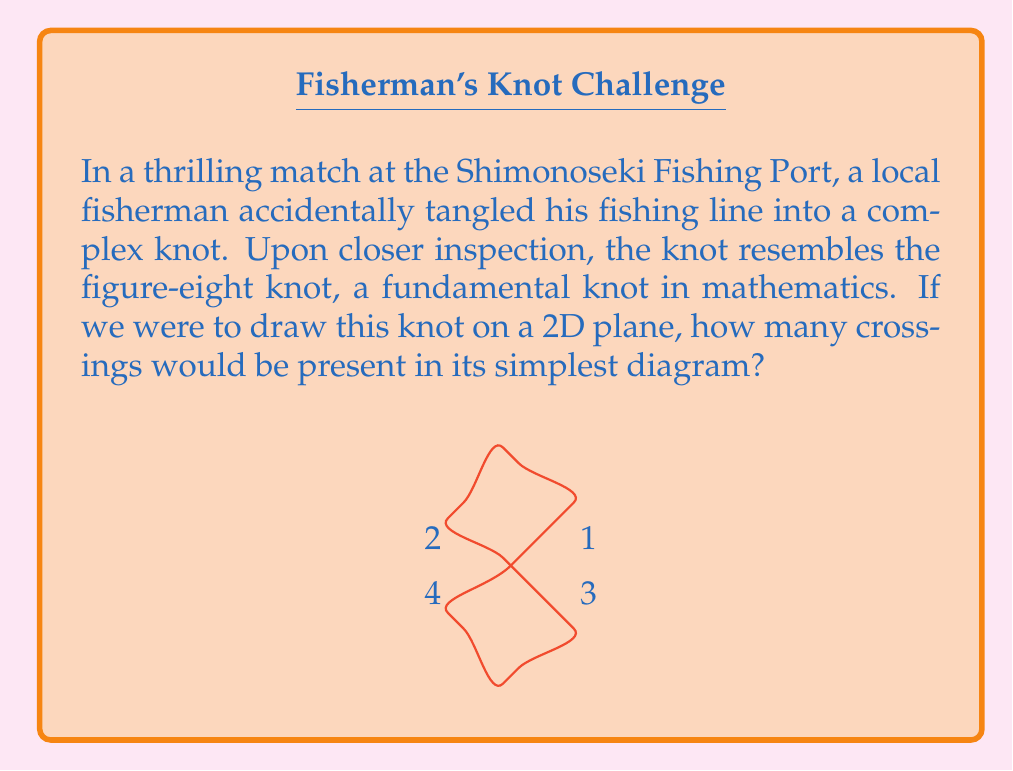Give your solution to this math problem. To determine the crossing number of a simple knot diagram, we need to follow these steps:

1) First, we need to understand what a crossing number is. The crossing number of a knot is the minimum number of crossings that occur in any projection of the knot onto a plane.

2) For the figure-eight knot, which is what our fisherman's tangled line resembles, we need to analyze its simplest diagram.

3) In the simplest diagram of a figure-eight knot, we can observe:
   - The knot crosses over itself four times.
   - These crossings are essential and cannot be removed or simplified further without changing the knot type.

4) We can verify this by tracing the knot:
   - Starting from any point, follow the line.
   - Count each time the line passes over or under another part of itself.
   - For the figure-eight knot, this count will always be 4 in its simplest form.

5) It's important to note that while more complex representations of the figure-eight knot might have more crossings, we're interested in the minimum number of crossings in any projection.

6) The figure-eight knot is known to be a prime knot, meaning it cannot be decomposed into simpler knots. This supports the fact that 4 is indeed the minimum number of crossings possible.

Therefore, the crossing number of the figure-eight knot, which our fisherman's tangled line resembles, is 4.
Answer: 4 